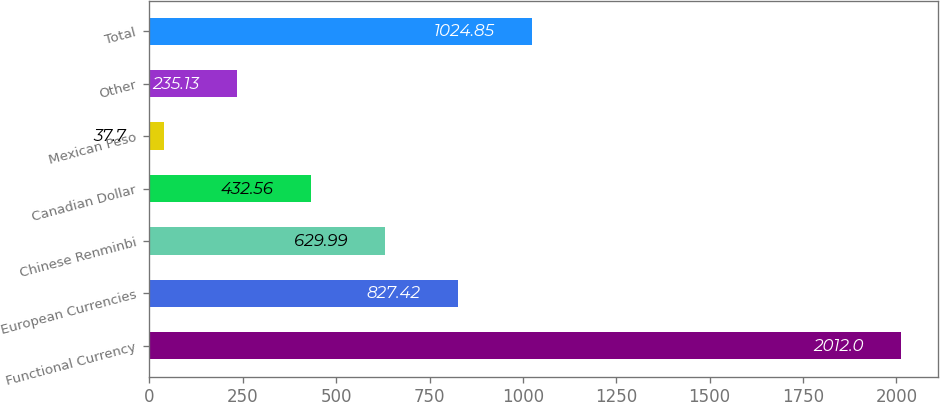<chart> <loc_0><loc_0><loc_500><loc_500><bar_chart><fcel>Functional Currency<fcel>European Currencies<fcel>Chinese Renminbi<fcel>Canadian Dollar<fcel>Mexican Peso<fcel>Other<fcel>Total<nl><fcel>2012<fcel>827.42<fcel>629.99<fcel>432.56<fcel>37.7<fcel>235.13<fcel>1024.85<nl></chart> 